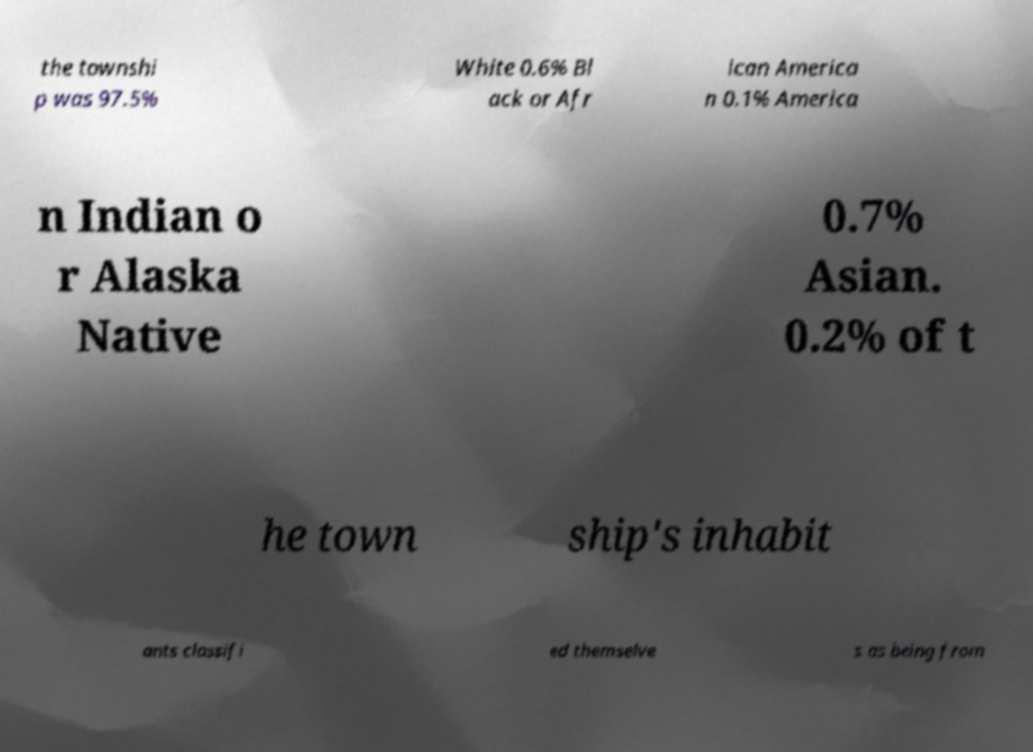Could you assist in decoding the text presented in this image and type it out clearly? the townshi p was 97.5% White 0.6% Bl ack or Afr ican America n 0.1% America n Indian o r Alaska Native 0.7% Asian. 0.2% of t he town ship's inhabit ants classifi ed themselve s as being from 